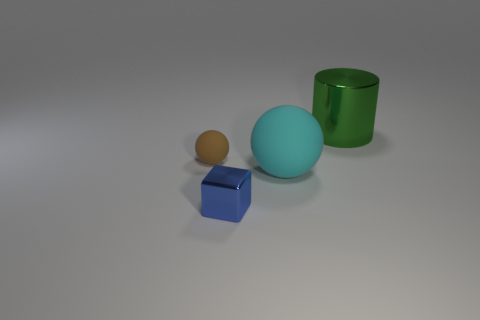There is a object that is right of the brown rubber sphere and behind the big matte thing; what material is it?
Give a very brief answer. Metal. Are any blue metallic things visible?
Ensure brevity in your answer.  Yes. What shape is the big thing that is made of the same material as the small blue object?
Offer a terse response. Cylinder. There is a brown rubber thing; does it have the same shape as the small thing that is in front of the brown rubber sphere?
Ensure brevity in your answer.  No. There is a tiny thing in front of the rubber ball behind the large cyan ball; what is it made of?
Offer a terse response. Metal. What number of other things are there of the same shape as the blue metal thing?
Your answer should be very brief. 0. There is a brown rubber thing on the left side of the large rubber sphere; is its shape the same as the rubber thing that is on the right side of the brown thing?
Offer a terse response. Yes. What is the material of the brown ball?
Your answer should be very brief. Rubber. There is a large thing in front of the large green metallic thing; what is it made of?
Your answer should be compact. Rubber. Are there any other things that are the same color as the big metallic cylinder?
Provide a succinct answer. No. 